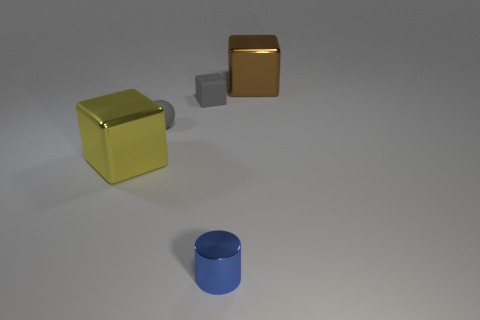Are there any small metallic cylinders in front of the yellow object?
Offer a very short reply. Yes. There is a shiny block that is in front of the big cube that is behind the yellow shiny thing; what color is it?
Ensure brevity in your answer.  Yellow. Are there fewer tiny blue shiny cylinders than big gray shiny things?
Make the answer very short. No. How many big brown metal things have the same shape as the yellow object?
Your answer should be very brief. 1. The metal cube that is the same size as the brown thing is what color?
Provide a succinct answer. Yellow. Is the number of yellow metallic cubes that are behind the tiny matte cube the same as the number of gray spheres that are in front of the tiny rubber sphere?
Ensure brevity in your answer.  Yes. Is there a thing that has the same size as the brown block?
Your answer should be compact. Yes. The brown block has what size?
Your answer should be very brief. Large. Are there an equal number of rubber blocks on the right side of the gray rubber ball and tiny matte things?
Provide a succinct answer. No. How many other things are the same color as the small cylinder?
Give a very brief answer. 0. 